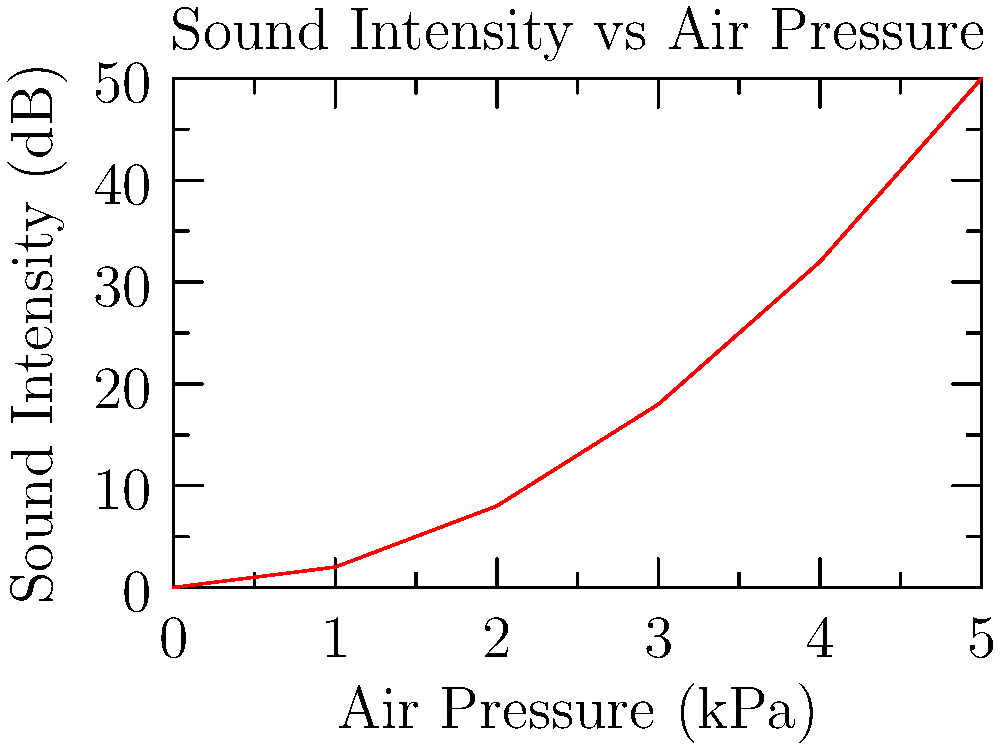Based on the graph showing the relationship between air pressure and sound intensity in wind instruments, what is the approximate rate of change in sound intensity (in dB) for every 1 kPa increase in air pressure between 2 kPa and 4 kPa? To solve this problem, we need to follow these steps:

1. Identify the sound intensity values at 2 kPa and 4 kPa:
   At 2 kPa: $y_1 = 8$ dB
   At 4 kPa: $y_2 = 32$ dB

2. Calculate the change in sound intensity:
   $\Delta y = y_2 - y_1 = 32 - 8 = 24$ dB

3. Calculate the change in air pressure:
   $\Delta x = 4 - 2 = 2$ kPa

4. Calculate the rate of change (slope) using the formula:
   Rate of change = $\frac{\Delta y}{\Delta x} = \frac{24 \text{ dB}}{2 \text{ kPa}} = 12 \text{ dB/kPa}$

Therefore, the sound intensity increases by approximately 12 dB for every 1 kPa increase in air pressure between 2 kPa and 4 kPa.
Answer: 12 dB/kPa 